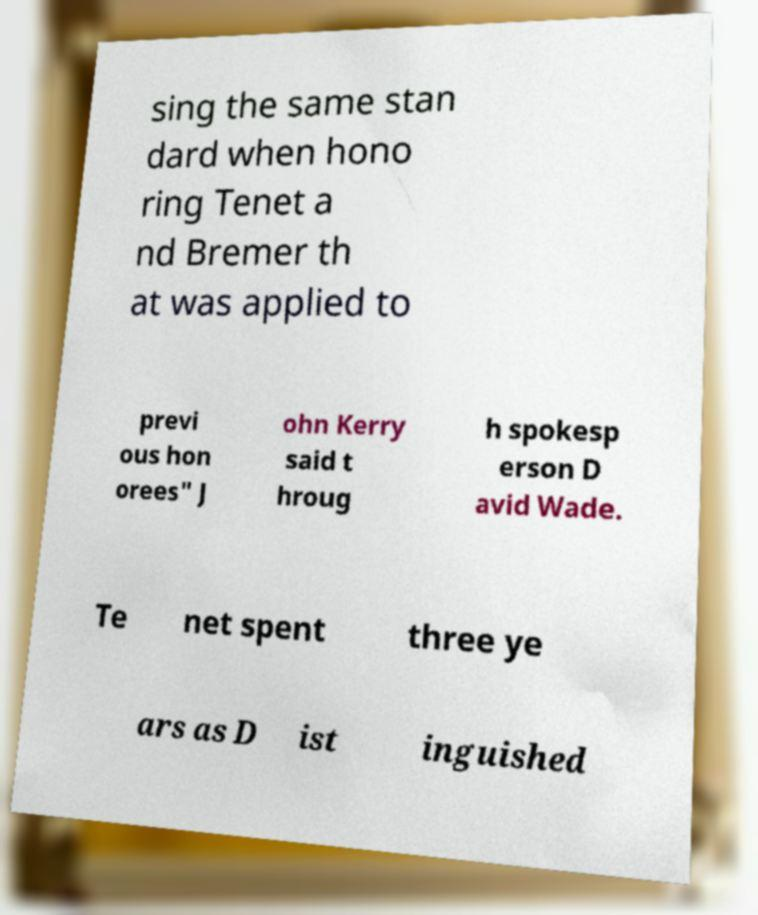Could you extract and type out the text from this image? sing the same stan dard when hono ring Tenet a nd Bremer th at was applied to previ ous hon orees" J ohn Kerry said t hroug h spokesp erson D avid Wade. Te net spent three ye ars as D ist inguished 